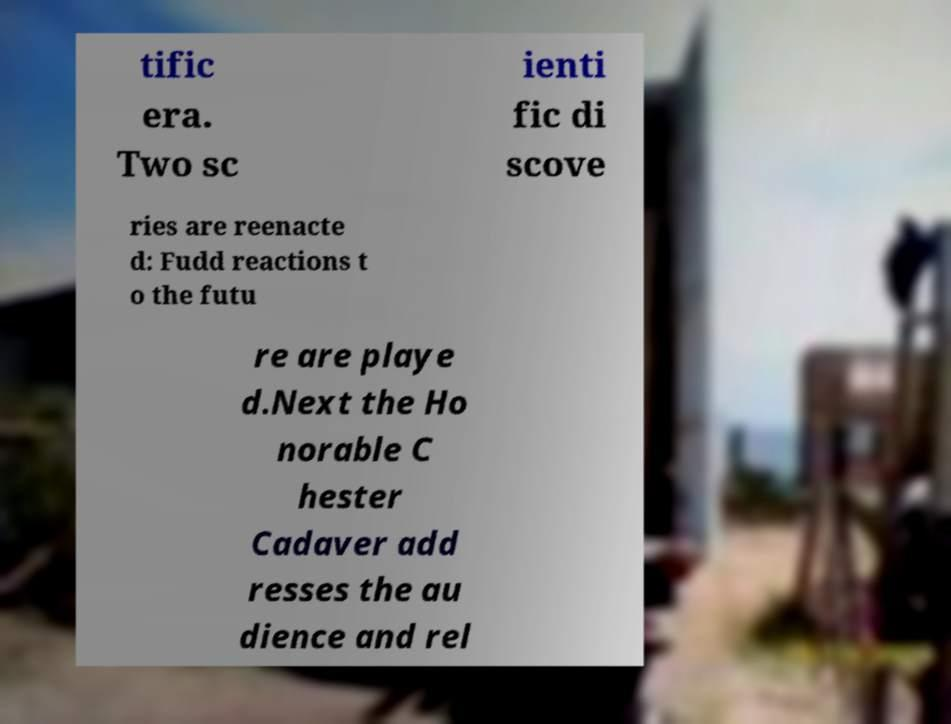Please read and relay the text visible in this image. What does it say? tific era. Two sc ienti fic di scove ries are reenacte d: Fudd reactions t o the futu re are playe d.Next the Ho norable C hester Cadaver add resses the au dience and rel 